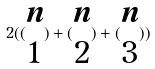<formula> <loc_0><loc_0><loc_500><loc_500>2 ( ( \begin{matrix} n \\ 1 \end{matrix} ) + ( \begin{matrix} n \\ 2 \end{matrix} ) + ( \begin{matrix} n \\ 3 \end{matrix} ) )</formula> 